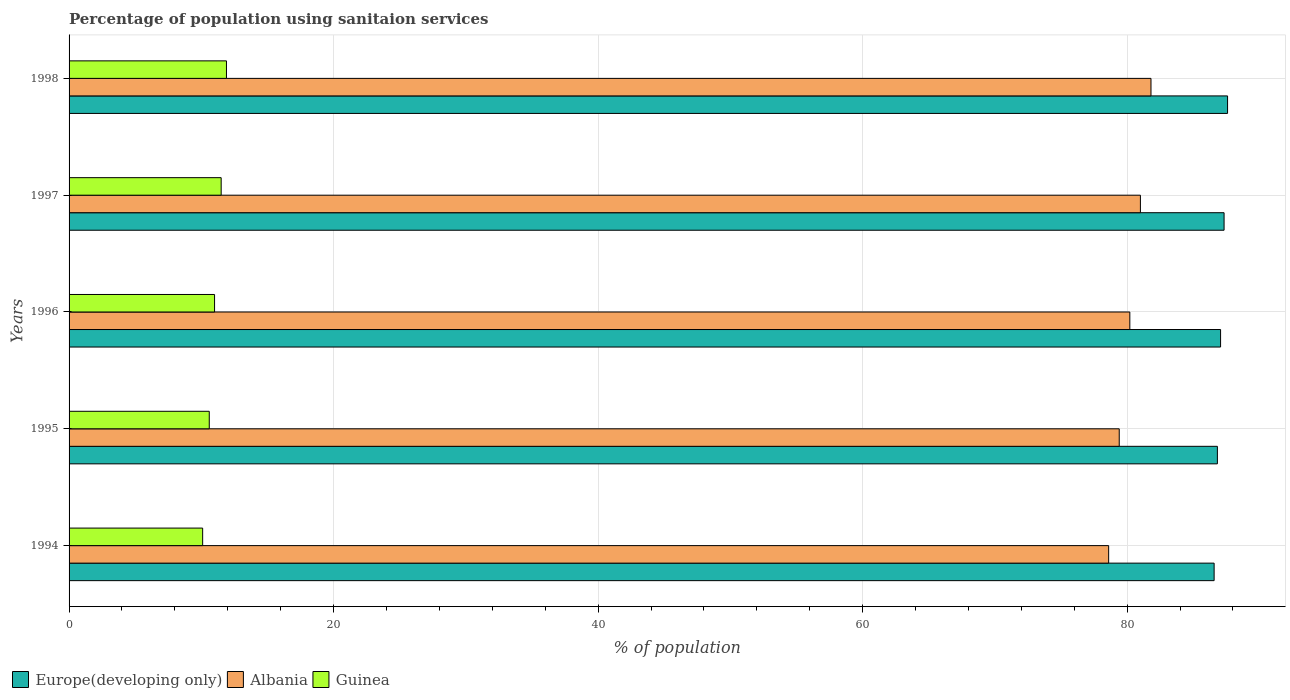How many groups of bars are there?
Make the answer very short. 5. How many bars are there on the 5th tick from the top?
Give a very brief answer. 3. In how many cases, is the number of bars for a given year not equal to the number of legend labels?
Your answer should be compact. 0. Across all years, what is the minimum percentage of population using sanitaion services in Guinea?
Offer a very short reply. 10.1. In which year was the percentage of population using sanitaion services in Europe(developing only) minimum?
Make the answer very short. 1994. What is the total percentage of population using sanitaion services in Guinea in the graph?
Keep it short and to the point. 55.1. What is the difference between the percentage of population using sanitaion services in Europe(developing only) in 1997 and that in 1998?
Ensure brevity in your answer.  -0.26. What is the difference between the percentage of population using sanitaion services in Europe(developing only) in 1994 and the percentage of population using sanitaion services in Guinea in 1996?
Give a very brief answer. 75.57. What is the average percentage of population using sanitaion services in Guinea per year?
Your answer should be very brief. 11.02. In the year 1997, what is the difference between the percentage of population using sanitaion services in Europe(developing only) and percentage of population using sanitaion services in Guinea?
Provide a short and direct response. 75.83. What is the ratio of the percentage of population using sanitaion services in Europe(developing only) in 1994 to that in 1996?
Offer a very short reply. 0.99. Is the percentage of population using sanitaion services in Guinea in 1995 less than that in 1997?
Your response must be concise. Yes. What is the difference between the highest and the second highest percentage of population using sanitaion services in Europe(developing only)?
Give a very brief answer. 0.26. What is the difference between the highest and the lowest percentage of population using sanitaion services in Guinea?
Offer a terse response. 1.8. In how many years, is the percentage of population using sanitaion services in Europe(developing only) greater than the average percentage of population using sanitaion services in Europe(developing only) taken over all years?
Your answer should be compact. 2. What does the 3rd bar from the top in 1997 represents?
Ensure brevity in your answer.  Europe(developing only). What does the 1st bar from the bottom in 1997 represents?
Make the answer very short. Europe(developing only). How many bars are there?
Offer a very short reply. 15. Are all the bars in the graph horizontal?
Keep it short and to the point. Yes. How many years are there in the graph?
Your answer should be compact. 5. What is the difference between two consecutive major ticks on the X-axis?
Keep it short and to the point. 20. Are the values on the major ticks of X-axis written in scientific E-notation?
Give a very brief answer. No. Does the graph contain any zero values?
Offer a terse response. No. How many legend labels are there?
Your answer should be very brief. 3. What is the title of the graph?
Offer a terse response. Percentage of population using sanitaion services. Does "Bhutan" appear as one of the legend labels in the graph?
Keep it short and to the point. No. What is the label or title of the X-axis?
Ensure brevity in your answer.  % of population. What is the label or title of the Y-axis?
Keep it short and to the point. Years. What is the % of population in Europe(developing only) in 1994?
Make the answer very short. 86.57. What is the % of population of Albania in 1994?
Your answer should be compact. 78.6. What is the % of population of Guinea in 1994?
Make the answer very short. 10.1. What is the % of population of Europe(developing only) in 1995?
Your answer should be very brief. 86.82. What is the % of population in Albania in 1995?
Provide a short and direct response. 79.4. What is the % of population in Guinea in 1995?
Your answer should be very brief. 10.6. What is the % of population in Europe(developing only) in 1996?
Provide a short and direct response. 87.06. What is the % of population in Albania in 1996?
Your answer should be very brief. 80.2. What is the % of population of Guinea in 1996?
Provide a succinct answer. 11. What is the % of population in Europe(developing only) in 1997?
Give a very brief answer. 87.33. What is the % of population in Albania in 1997?
Your answer should be very brief. 81. What is the % of population of Guinea in 1997?
Give a very brief answer. 11.5. What is the % of population of Europe(developing only) in 1998?
Provide a succinct answer. 87.59. What is the % of population of Albania in 1998?
Ensure brevity in your answer.  81.8. What is the % of population in Guinea in 1998?
Give a very brief answer. 11.9. Across all years, what is the maximum % of population of Europe(developing only)?
Your response must be concise. 87.59. Across all years, what is the maximum % of population in Albania?
Provide a short and direct response. 81.8. Across all years, what is the maximum % of population of Guinea?
Ensure brevity in your answer.  11.9. Across all years, what is the minimum % of population of Europe(developing only)?
Provide a succinct answer. 86.57. Across all years, what is the minimum % of population of Albania?
Ensure brevity in your answer.  78.6. What is the total % of population in Europe(developing only) in the graph?
Offer a very short reply. 435.37. What is the total % of population in Albania in the graph?
Your response must be concise. 401. What is the total % of population of Guinea in the graph?
Keep it short and to the point. 55.1. What is the difference between the % of population of Europe(developing only) in 1994 and that in 1995?
Make the answer very short. -0.25. What is the difference between the % of population in Albania in 1994 and that in 1995?
Your answer should be compact. -0.8. What is the difference between the % of population in Europe(developing only) in 1994 and that in 1996?
Your answer should be very brief. -0.49. What is the difference between the % of population in Europe(developing only) in 1994 and that in 1997?
Provide a short and direct response. -0.75. What is the difference between the % of population in Europe(developing only) in 1994 and that in 1998?
Give a very brief answer. -1.02. What is the difference between the % of population of Europe(developing only) in 1995 and that in 1996?
Your response must be concise. -0.24. What is the difference between the % of population of Albania in 1995 and that in 1996?
Your answer should be very brief. -0.8. What is the difference between the % of population of Europe(developing only) in 1995 and that in 1997?
Your response must be concise. -0.51. What is the difference between the % of population of Guinea in 1995 and that in 1997?
Give a very brief answer. -0.9. What is the difference between the % of population in Europe(developing only) in 1995 and that in 1998?
Your response must be concise. -0.77. What is the difference between the % of population in Europe(developing only) in 1996 and that in 1997?
Keep it short and to the point. -0.26. What is the difference between the % of population of Albania in 1996 and that in 1997?
Offer a very short reply. -0.8. What is the difference between the % of population in Guinea in 1996 and that in 1997?
Keep it short and to the point. -0.5. What is the difference between the % of population in Europe(developing only) in 1996 and that in 1998?
Your answer should be compact. -0.53. What is the difference between the % of population of Albania in 1996 and that in 1998?
Your response must be concise. -1.6. What is the difference between the % of population in Guinea in 1996 and that in 1998?
Make the answer very short. -0.9. What is the difference between the % of population of Europe(developing only) in 1997 and that in 1998?
Provide a short and direct response. -0.26. What is the difference between the % of population of Europe(developing only) in 1994 and the % of population of Albania in 1995?
Your response must be concise. 7.17. What is the difference between the % of population in Europe(developing only) in 1994 and the % of population in Guinea in 1995?
Your response must be concise. 75.97. What is the difference between the % of population in Albania in 1994 and the % of population in Guinea in 1995?
Offer a terse response. 68. What is the difference between the % of population of Europe(developing only) in 1994 and the % of population of Albania in 1996?
Provide a succinct answer. 6.37. What is the difference between the % of population in Europe(developing only) in 1994 and the % of population in Guinea in 1996?
Offer a very short reply. 75.57. What is the difference between the % of population in Albania in 1994 and the % of population in Guinea in 1996?
Provide a short and direct response. 67.6. What is the difference between the % of population in Europe(developing only) in 1994 and the % of population in Albania in 1997?
Keep it short and to the point. 5.57. What is the difference between the % of population of Europe(developing only) in 1994 and the % of population of Guinea in 1997?
Provide a short and direct response. 75.07. What is the difference between the % of population of Albania in 1994 and the % of population of Guinea in 1997?
Provide a short and direct response. 67.1. What is the difference between the % of population in Europe(developing only) in 1994 and the % of population in Albania in 1998?
Your answer should be compact. 4.77. What is the difference between the % of population of Europe(developing only) in 1994 and the % of population of Guinea in 1998?
Provide a short and direct response. 74.67. What is the difference between the % of population of Albania in 1994 and the % of population of Guinea in 1998?
Offer a very short reply. 66.7. What is the difference between the % of population in Europe(developing only) in 1995 and the % of population in Albania in 1996?
Keep it short and to the point. 6.62. What is the difference between the % of population in Europe(developing only) in 1995 and the % of population in Guinea in 1996?
Your answer should be very brief. 75.82. What is the difference between the % of population of Albania in 1995 and the % of population of Guinea in 1996?
Give a very brief answer. 68.4. What is the difference between the % of population of Europe(developing only) in 1995 and the % of population of Albania in 1997?
Provide a short and direct response. 5.82. What is the difference between the % of population of Europe(developing only) in 1995 and the % of population of Guinea in 1997?
Your response must be concise. 75.32. What is the difference between the % of population of Albania in 1995 and the % of population of Guinea in 1997?
Your answer should be very brief. 67.9. What is the difference between the % of population in Europe(developing only) in 1995 and the % of population in Albania in 1998?
Give a very brief answer. 5.02. What is the difference between the % of population in Europe(developing only) in 1995 and the % of population in Guinea in 1998?
Give a very brief answer. 74.92. What is the difference between the % of population of Albania in 1995 and the % of population of Guinea in 1998?
Give a very brief answer. 67.5. What is the difference between the % of population of Europe(developing only) in 1996 and the % of population of Albania in 1997?
Your answer should be compact. 6.06. What is the difference between the % of population of Europe(developing only) in 1996 and the % of population of Guinea in 1997?
Give a very brief answer. 75.56. What is the difference between the % of population in Albania in 1996 and the % of population in Guinea in 1997?
Your response must be concise. 68.7. What is the difference between the % of population in Europe(developing only) in 1996 and the % of population in Albania in 1998?
Give a very brief answer. 5.26. What is the difference between the % of population in Europe(developing only) in 1996 and the % of population in Guinea in 1998?
Your response must be concise. 75.16. What is the difference between the % of population of Albania in 1996 and the % of population of Guinea in 1998?
Keep it short and to the point. 68.3. What is the difference between the % of population of Europe(developing only) in 1997 and the % of population of Albania in 1998?
Your response must be concise. 5.53. What is the difference between the % of population of Europe(developing only) in 1997 and the % of population of Guinea in 1998?
Provide a succinct answer. 75.43. What is the difference between the % of population of Albania in 1997 and the % of population of Guinea in 1998?
Keep it short and to the point. 69.1. What is the average % of population in Europe(developing only) per year?
Make the answer very short. 87.07. What is the average % of population of Albania per year?
Your answer should be very brief. 80.2. What is the average % of population of Guinea per year?
Your answer should be compact. 11.02. In the year 1994, what is the difference between the % of population in Europe(developing only) and % of population in Albania?
Ensure brevity in your answer.  7.97. In the year 1994, what is the difference between the % of population of Europe(developing only) and % of population of Guinea?
Make the answer very short. 76.47. In the year 1994, what is the difference between the % of population of Albania and % of population of Guinea?
Offer a very short reply. 68.5. In the year 1995, what is the difference between the % of population in Europe(developing only) and % of population in Albania?
Give a very brief answer. 7.42. In the year 1995, what is the difference between the % of population of Europe(developing only) and % of population of Guinea?
Your response must be concise. 76.22. In the year 1995, what is the difference between the % of population in Albania and % of population in Guinea?
Give a very brief answer. 68.8. In the year 1996, what is the difference between the % of population of Europe(developing only) and % of population of Albania?
Make the answer very short. 6.86. In the year 1996, what is the difference between the % of population in Europe(developing only) and % of population in Guinea?
Ensure brevity in your answer.  76.06. In the year 1996, what is the difference between the % of population in Albania and % of population in Guinea?
Offer a terse response. 69.2. In the year 1997, what is the difference between the % of population in Europe(developing only) and % of population in Albania?
Ensure brevity in your answer.  6.33. In the year 1997, what is the difference between the % of population in Europe(developing only) and % of population in Guinea?
Make the answer very short. 75.83. In the year 1997, what is the difference between the % of population in Albania and % of population in Guinea?
Provide a succinct answer. 69.5. In the year 1998, what is the difference between the % of population in Europe(developing only) and % of population in Albania?
Your answer should be compact. 5.79. In the year 1998, what is the difference between the % of population in Europe(developing only) and % of population in Guinea?
Offer a terse response. 75.69. In the year 1998, what is the difference between the % of population of Albania and % of population of Guinea?
Provide a short and direct response. 69.9. What is the ratio of the % of population in Europe(developing only) in 1994 to that in 1995?
Offer a very short reply. 1. What is the ratio of the % of population of Albania in 1994 to that in 1995?
Offer a very short reply. 0.99. What is the ratio of the % of population of Guinea in 1994 to that in 1995?
Provide a succinct answer. 0.95. What is the ratio of the % of population in Albania in 1994 to that in 1996?
Provide a short and direct response. 0.98. What is the ratio of the % of population of Guinea in 1994 to that in 1996?
Your answer should be very brief. 0.92. What is the ratio of the % of population of Europe(developing only) in 1994 to that in 1997?
Make the answer very short. 0.99. What is the ratio of the % of population in Albania in 1994 to that in 1997?
Keep it short and to the point. 0.97. What is the ratio of the % of population of Guinea in 1994 to that in 1997?
Provide a short and direct response. 0.88. What is the ratio of the % of population of Europe(developing only) in 1994 to that in 1998?
Your answer should be compact. 0.99. What is the ratio of the % of population of Albania in 1994 to that in 1998?
Provide a short and direct response. 0.96. What is the ratio of the % of population of Guinea in 1994 to that in 1998?
Offer a very short reply. 0.85. What is the ratio of the % of population in Europe(developing only) in 1995 to that in 1996?
Your answer should be compact. 1. What is the ratio of the % of population in Albania in 1995 to that in 1996?
Ensure brevity in your answer.  0.99. What is the ratio of the % of population of Guinea in 1995 to that in 1996?
Your answer should be very brief. 0.96. What is the ratio of the % of population of Europe(developing only) in 1995 to that in 1997?
Offer a very short reply. 0.99. What is the ratio of the % of population of Albania in 1995 to that in 1997?
Provide a succinct answer. 0.98. What is the ratio of the % of population in Guinea in 1995 to that in 1997?
Your answer should be compact. 0.92. What is the ratio of the % of population in Europe(developing only) in 1995 to that in 1998?
Provide a succinct answer. 0.99. What is the ratio of the % of population in Albania in 1995 to that in 1998?
Make the answer very short. 0.97. What is the ratio of the % of population in Guinea in 1995 to that in 1998?
Offer a very short reply. 0.89. What is the ratio of the % of population of Europe(developing only) in 1996 to that in 1997?
Make the answer very short. 1. What is the ratio of the % of population in Guinea in 1996 to that in 1997?
Offer a terse response. 0.96. What is the ratio of the % of population in Albania in 1996 to that in 1998?
Give a very brief answer. 0.98. What is the ratio of the % of population of Guinea in 1996 to that in 1998?
Keep it short and to the point. 0.92. What is the ratio of the % of population of Europe(developing only) in 1997 to that in 1998?
Your answer should be very brief. 1. What is the ratio of the % of population of Albania in 1997 to that in 1998?
Keep it short and to the point. 0.99. What is the ratio of the % of population of Guinea in 1997 to that in 1998?
Provide a succinct answer. 0.97. What is the difference between the highest and the second highest % of population of Europe(developing only)?
Your answer should be compact. 0.26. What is the difference between the highest and the second highest % of population in Albania?
Offer a very short reply. 0.8. What is the difference between the highest and the second highest % of population of Guinea?
Offer a very short reply. 0.4. What is the difference between the highest and the lowest % of population in Europe(developing only)?
Provide a succinct answer. 1.02. What is the difference between the highest and the lowest % of population of Albania?
Provide a succinct answer. 3.2. What is the difference between the highest and the lowest % of population in Guinea?
Your answer should be very brief. 1.8. 